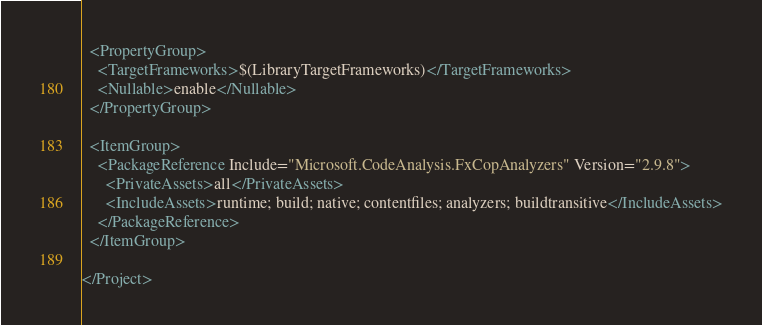<code> <loc_0><loc_0><loc_500><loc_500><_XML_>  <PropertyGroup>
    <TargetFrameworks>$(LibraryTargetFrameworks)</TargetFrameworks>
    <Nullable>enable</Nullable>
  </PropertyGroup>

  <ItemGroup>
    <PackageReference Include="Microsoft.CodeAnalysis.FxCopAnalyzers" Version="2.9.8">
      <PrivateAssets>all</PrivateAssets>
      <IncludeAssets>runtime; build; native; contentfiles; analyzers; buildtransitive</IncludeAssets>
    </PackageReference>
  </ItemGroup>

</Project>
</code> 